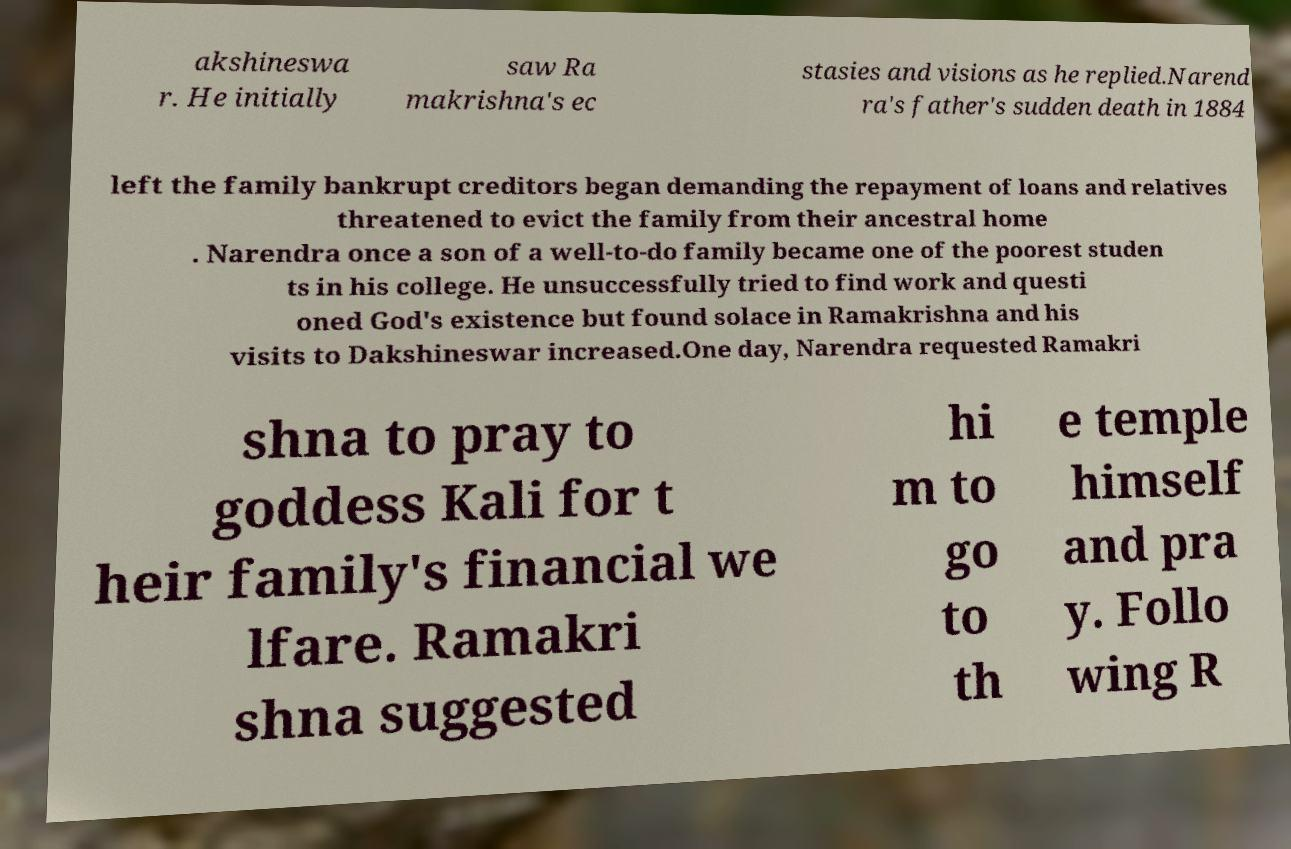Please read and relay the text visible in this image. What does it say? akshineswa r. He initially saw Ra makrishna's ec stasies and visions as he replied.Narend ra's father's sudden death in 1884 left the family bankrupt creditors began demanding the repayment of loans and relatives threatened to evict the family from their ancestral home . Narendra once a son of a well-to-do family became one of the poorest studen ts in his college. He unsuccessfully tried to find work and questi oned God's existence but found solace in Ramakrishna and his visits to Dakshineswar increased.One day, Narendra requested Ramakri shna to pray to goddess Kali for t heir family's financial we lfare. Ramakri shna suggested hi m to go to th e temple himself and pra y. Follo wing R 